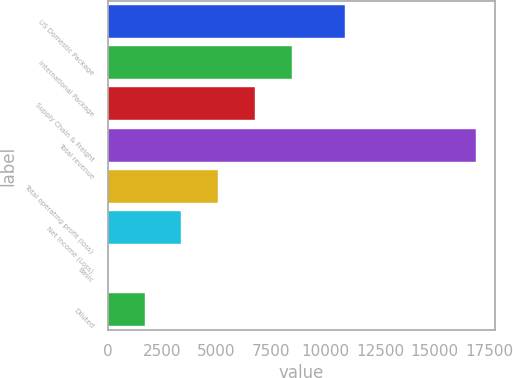Convert chart to OTSL. <chart><loc_0><loc_0><loc_500><loc_500><bar_chart><fcel>US Domestic Package<fcel>International Package<fcel>Supply Chain & Freight<fcel>Total revenue<fcel>Total operating profit (loss)<fcel>Net Income (Loss)<fcel>Basic<fcel>Diluted<nl><fcel>10913<fcel>8465.62<fcel>6772.55<fcel>16931<fcel>5079.48<fcel>3386.41<fcel>0.27<fcel>1693.34<nl></chart> 